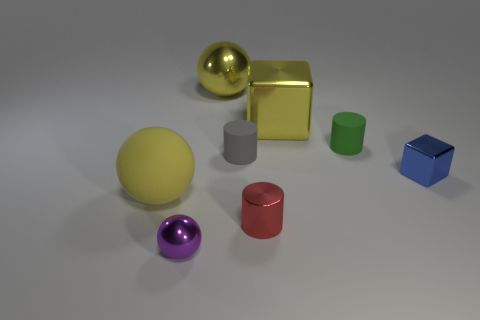Add 2 red objects. How many objects exist? 10 Subtract all cubes. How many objects are left? 6 Subtract 0 gray cubes. How many objects are left? 8 Subtract all big blocks. Subtract all blue cubes. How many objects are left? 6 Add 1 gray rubber cylinders. How many gray rubber cylinders are left? 2 Add 5 big green matte objects. How many big green matte objects exist? 5 